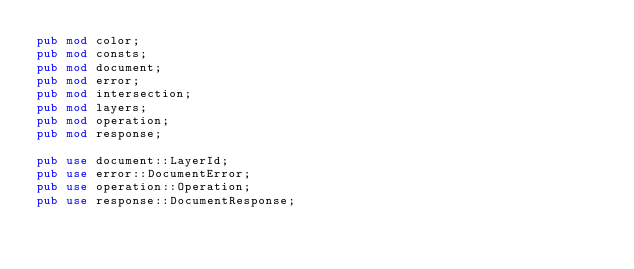Convert code to text. <code><loc_0><loc_0><loc_500><loc_500><_Rust_>pub mod color;
pub mod consts;
pub mod document;
pub mod error;
pub mod intersection;
pub mod layers;
pub mod operation;
pub mod response;

pub use document::LayerId;
pub use error::DocumentError;
pub use operation::Operation;
pub use response::DocumentResponse;
</code> 